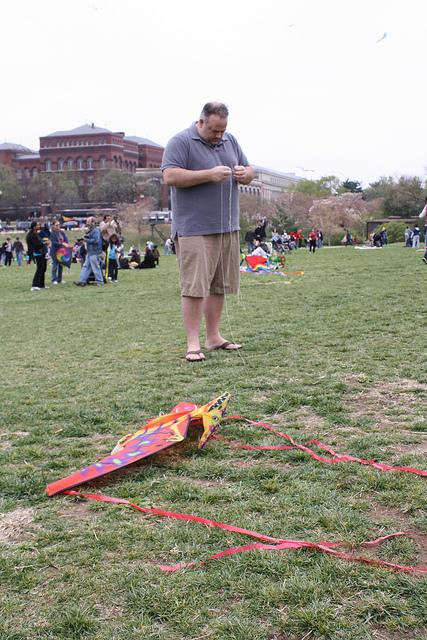What is the red object on the ground capable of? Please explain your reasoning. flight. It is a kite that is fun to use in the wind 